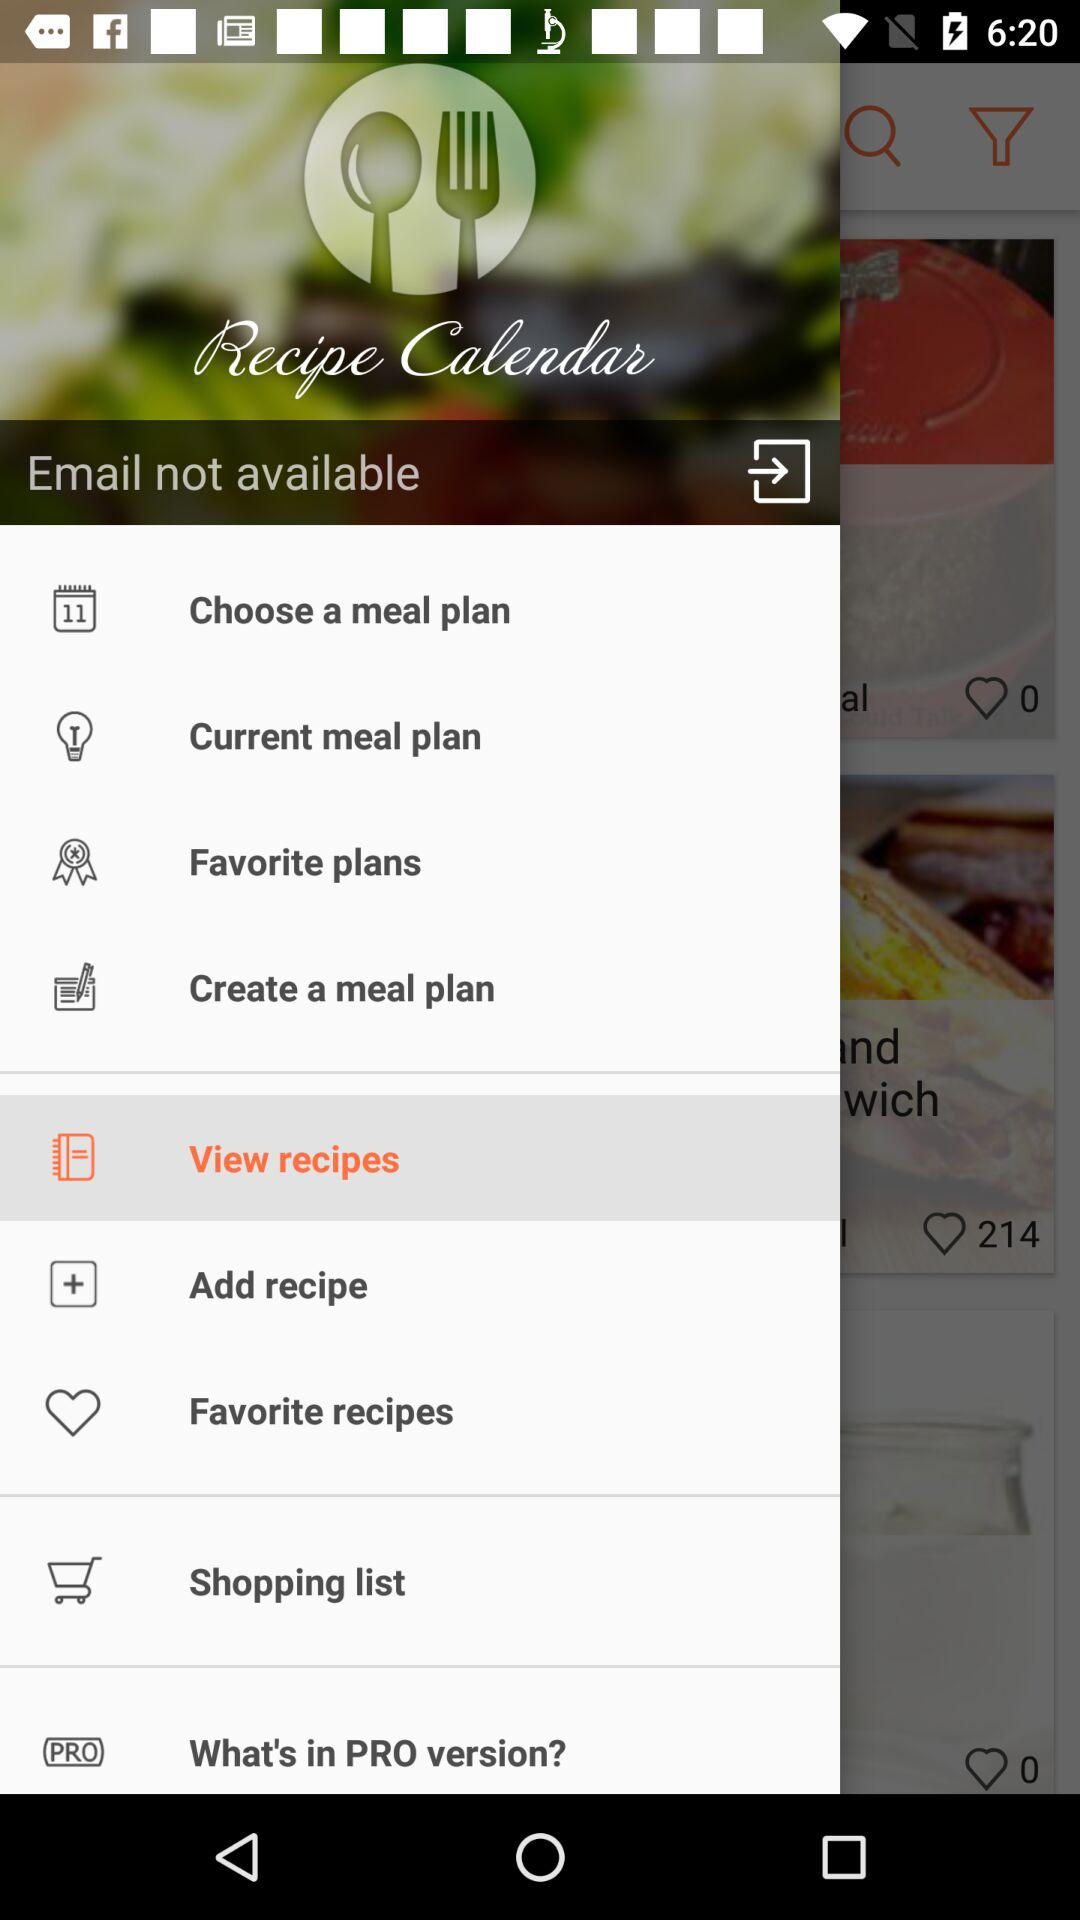Which meal plans are in "Favorite plans"?
When the provided information is insufficient, respond with <no answer>. <no answer> 